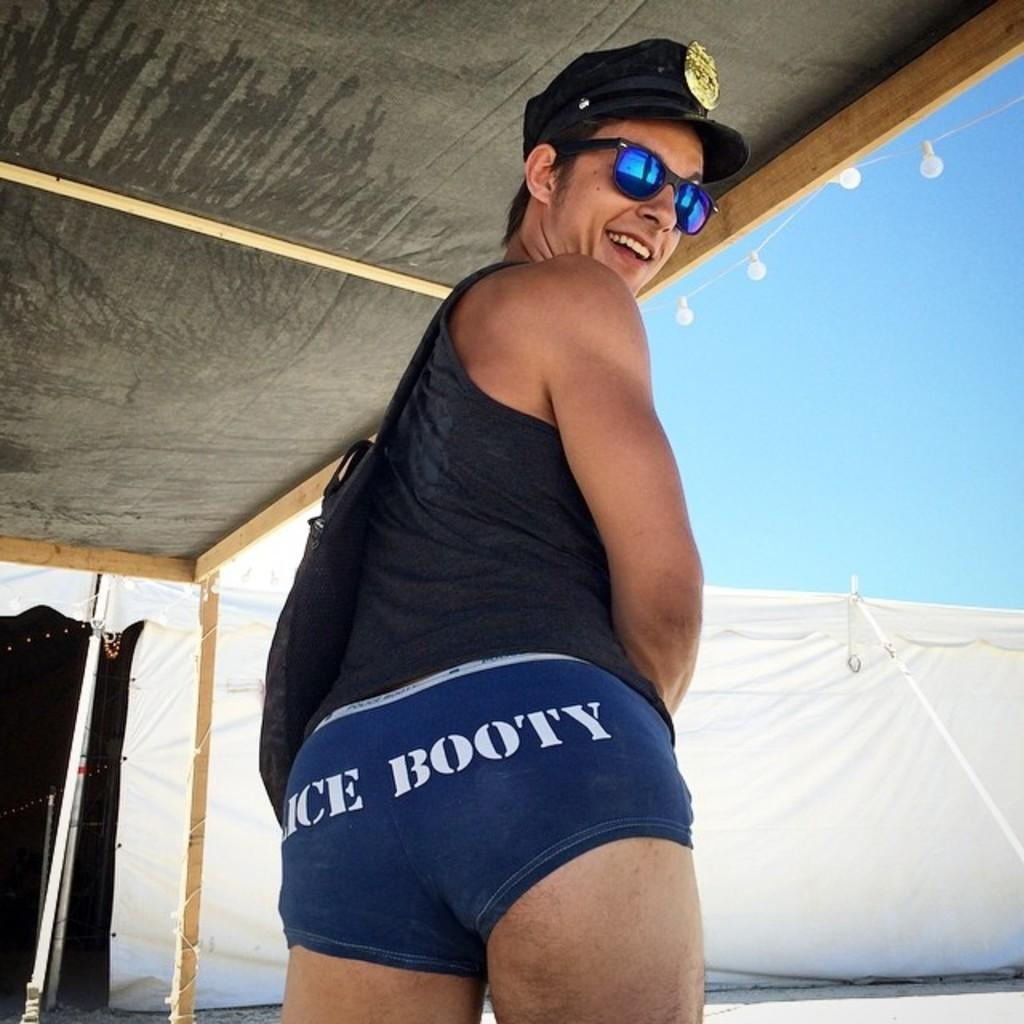What is the person in the image wearing? The person in the image is wearing a dress. Where is the person located in the image? The person is under a shed. What can be seen near the shed in the image? There are lights near the shed in the image. What is visible in the background of the image? There is a tent and the sky visible in the background of the image. What type of punishment is being administered to the dolls in the image? There are no dolls present in the image, and therefore no punishment is being administered. 